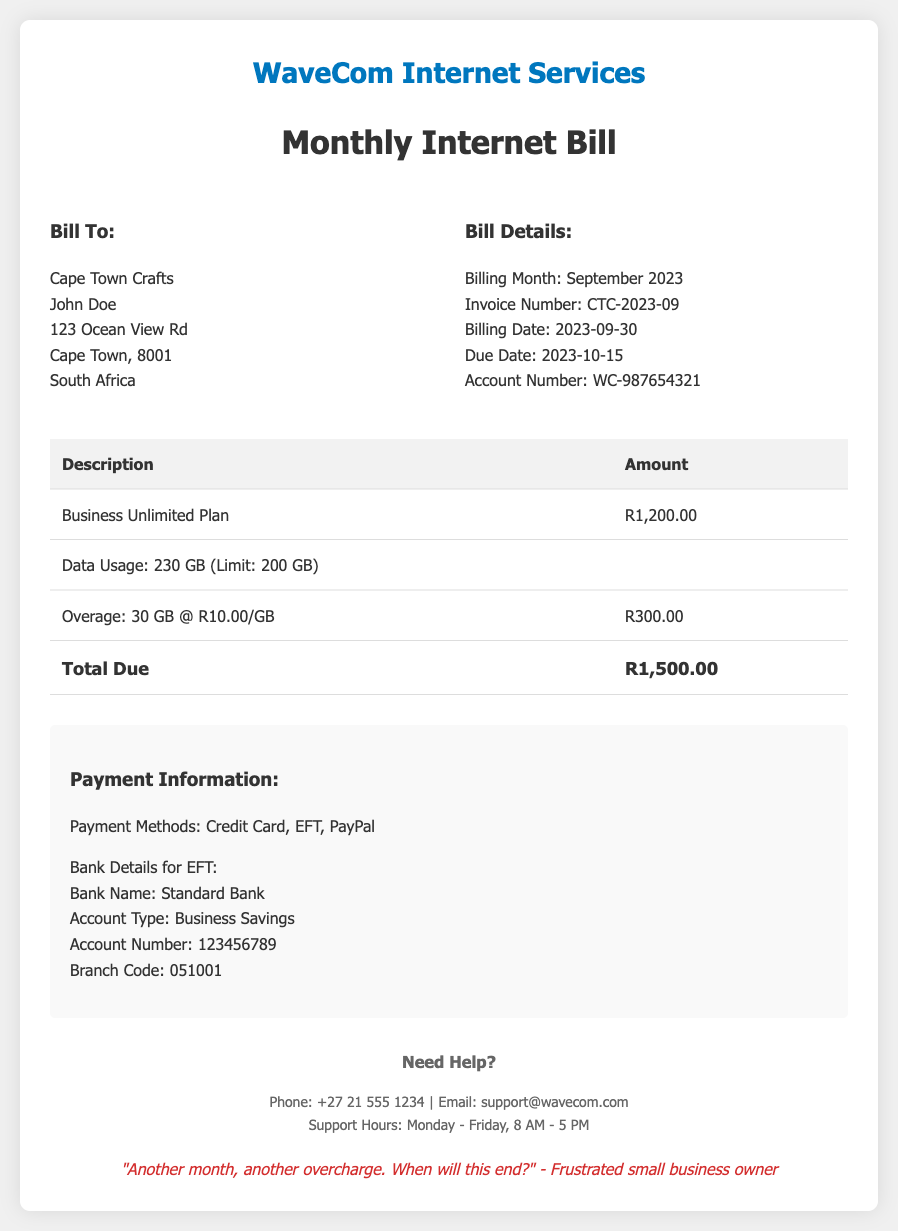What is the total amount due? The total amount due is listed clearly in the bill as R1,500.00.
Answer: R1,500.00 What is the account number? The account number is provided in the billing details section of the document.
Answer: WC-987654321 Which plan is included in the bill? The plan mentioned is the "Business Unlimited Plan."
Answer: Business Unlimited Plan How much was the overage fee? The overage fee is specified as R300.00 in the table.
Answer: R300.00 What is the data limit for the plan? The data limit for the plan is stated as 200 GB.
Answer: 200 GB What is the invoice number? The invoice number can be found in the billing details section.
Answer: CTC-2023-09 When is the due date for the payment? The due date for payment is specified in the billing details section.
Answer: 2023-10-15 How many GB were used in total? The total data used is mentioned in the bill as 230 GB.
Answer: 230 GB What is the contact phone number for support? The support phone number is provided in the contact info section.
Answer: +27 21 555 1234 